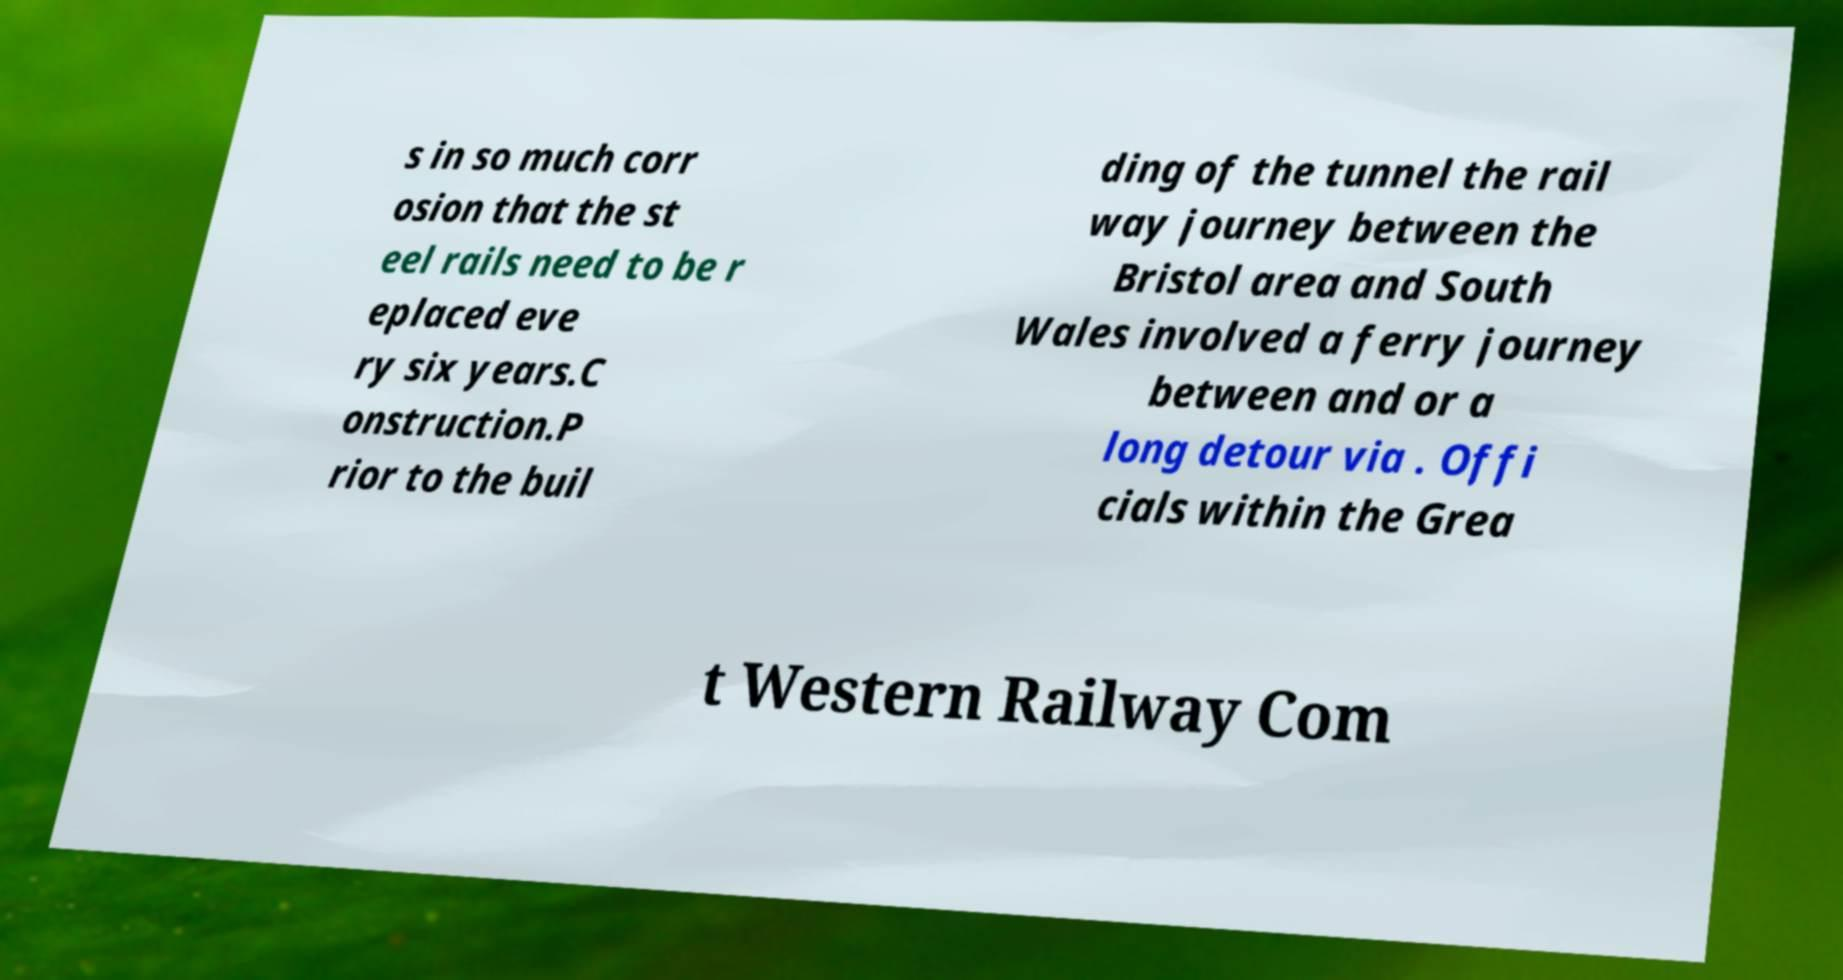For documentation purposes, I need the text within this image transcribed. Could you provide that? s in so much corr osion that the st eel rails need to be r eplaced eve ry six years.C onstruction.P rior to the buil ding of the tunnel the rail way journey between the Bristol area and South Wales involved a ferry journey between and or a long detour via . Offi cials within the Grea t Western Railway Com 